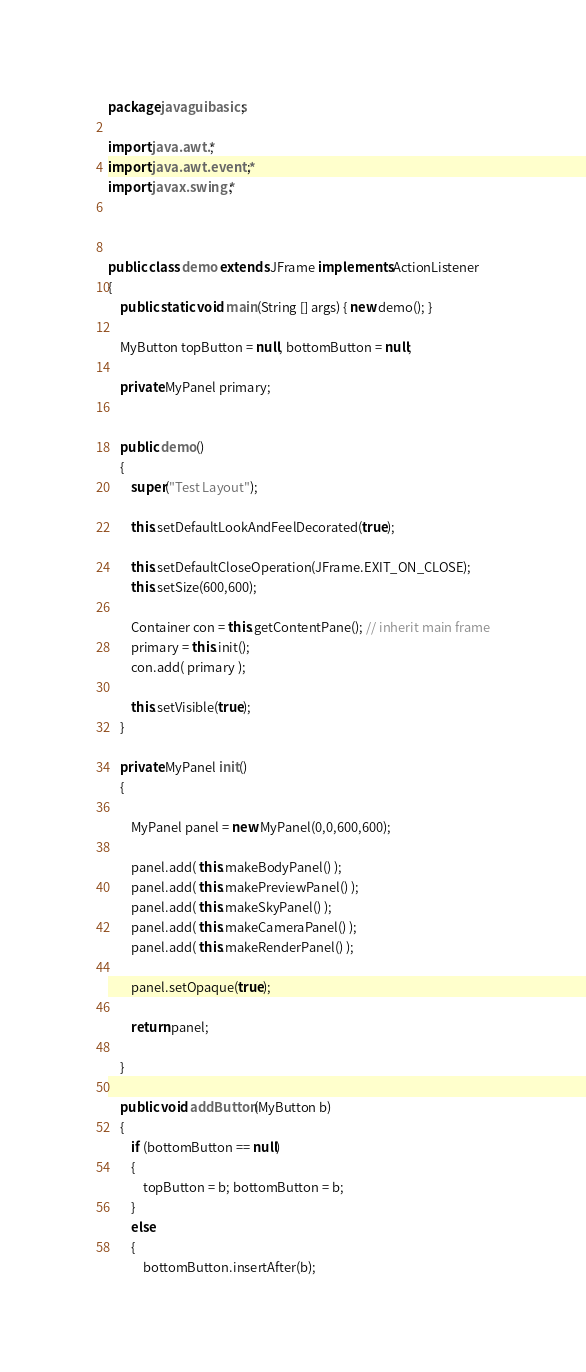Convert code to text. <code><loc_0><loc_0><loc_500><loc_500><_Java_>
package javaguibasics;

import java.awt.*;
import java.awt.event.*;
import javax.swing.*;



public class demo extends JFrame implements ActionListener
{
	public static void main(String [] args) { new demo(); }
	
	MyButton topButton = null, bottomButton = null;
	
	private MyPanel primary;
	
	
	public demo()
	{
		super("Test Layout");
		
		this.setDefaultLookAndFeelDecorated(true);
		
		this.setDefaultCloseOperation(JFrame.EXIT_ON_CLOSE);
		this.setSize(600,600);
		
		Container con = this.getContentPane(); // inherit main frame
		primary = this.init();
		con.add( primary );
		
		this.setVisible(true);
	}
	
	private MyPanel init()
	{
		
		MyPanel panel = new MyPanel(0,0,600,600);
		
		panel.add( this.makeBodyPanel() );
		panel.add( this.makePreviewPanel() );
		panel.add( this.makeSkyPanel() );
		panel.add( this.makeCameraPanel() );
		panel.add( this.makeRenderPanel() );
		
		panel.setOpaque(true);
		
		return panel;
		
	}
	
	public void addButton(MyButton b)
	{
		if (bottomButton == null)
		{
			topButton = b; bottomButton = b;
		}
		else
		{
			bottomButton.insertAfter(b);</code> 